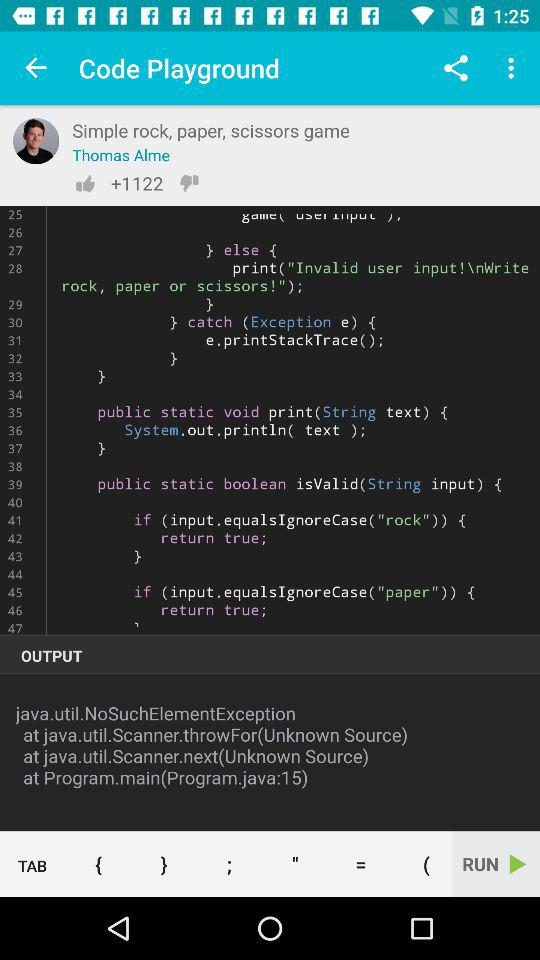What is the name of the application? The name of the application is "Code Playground". 